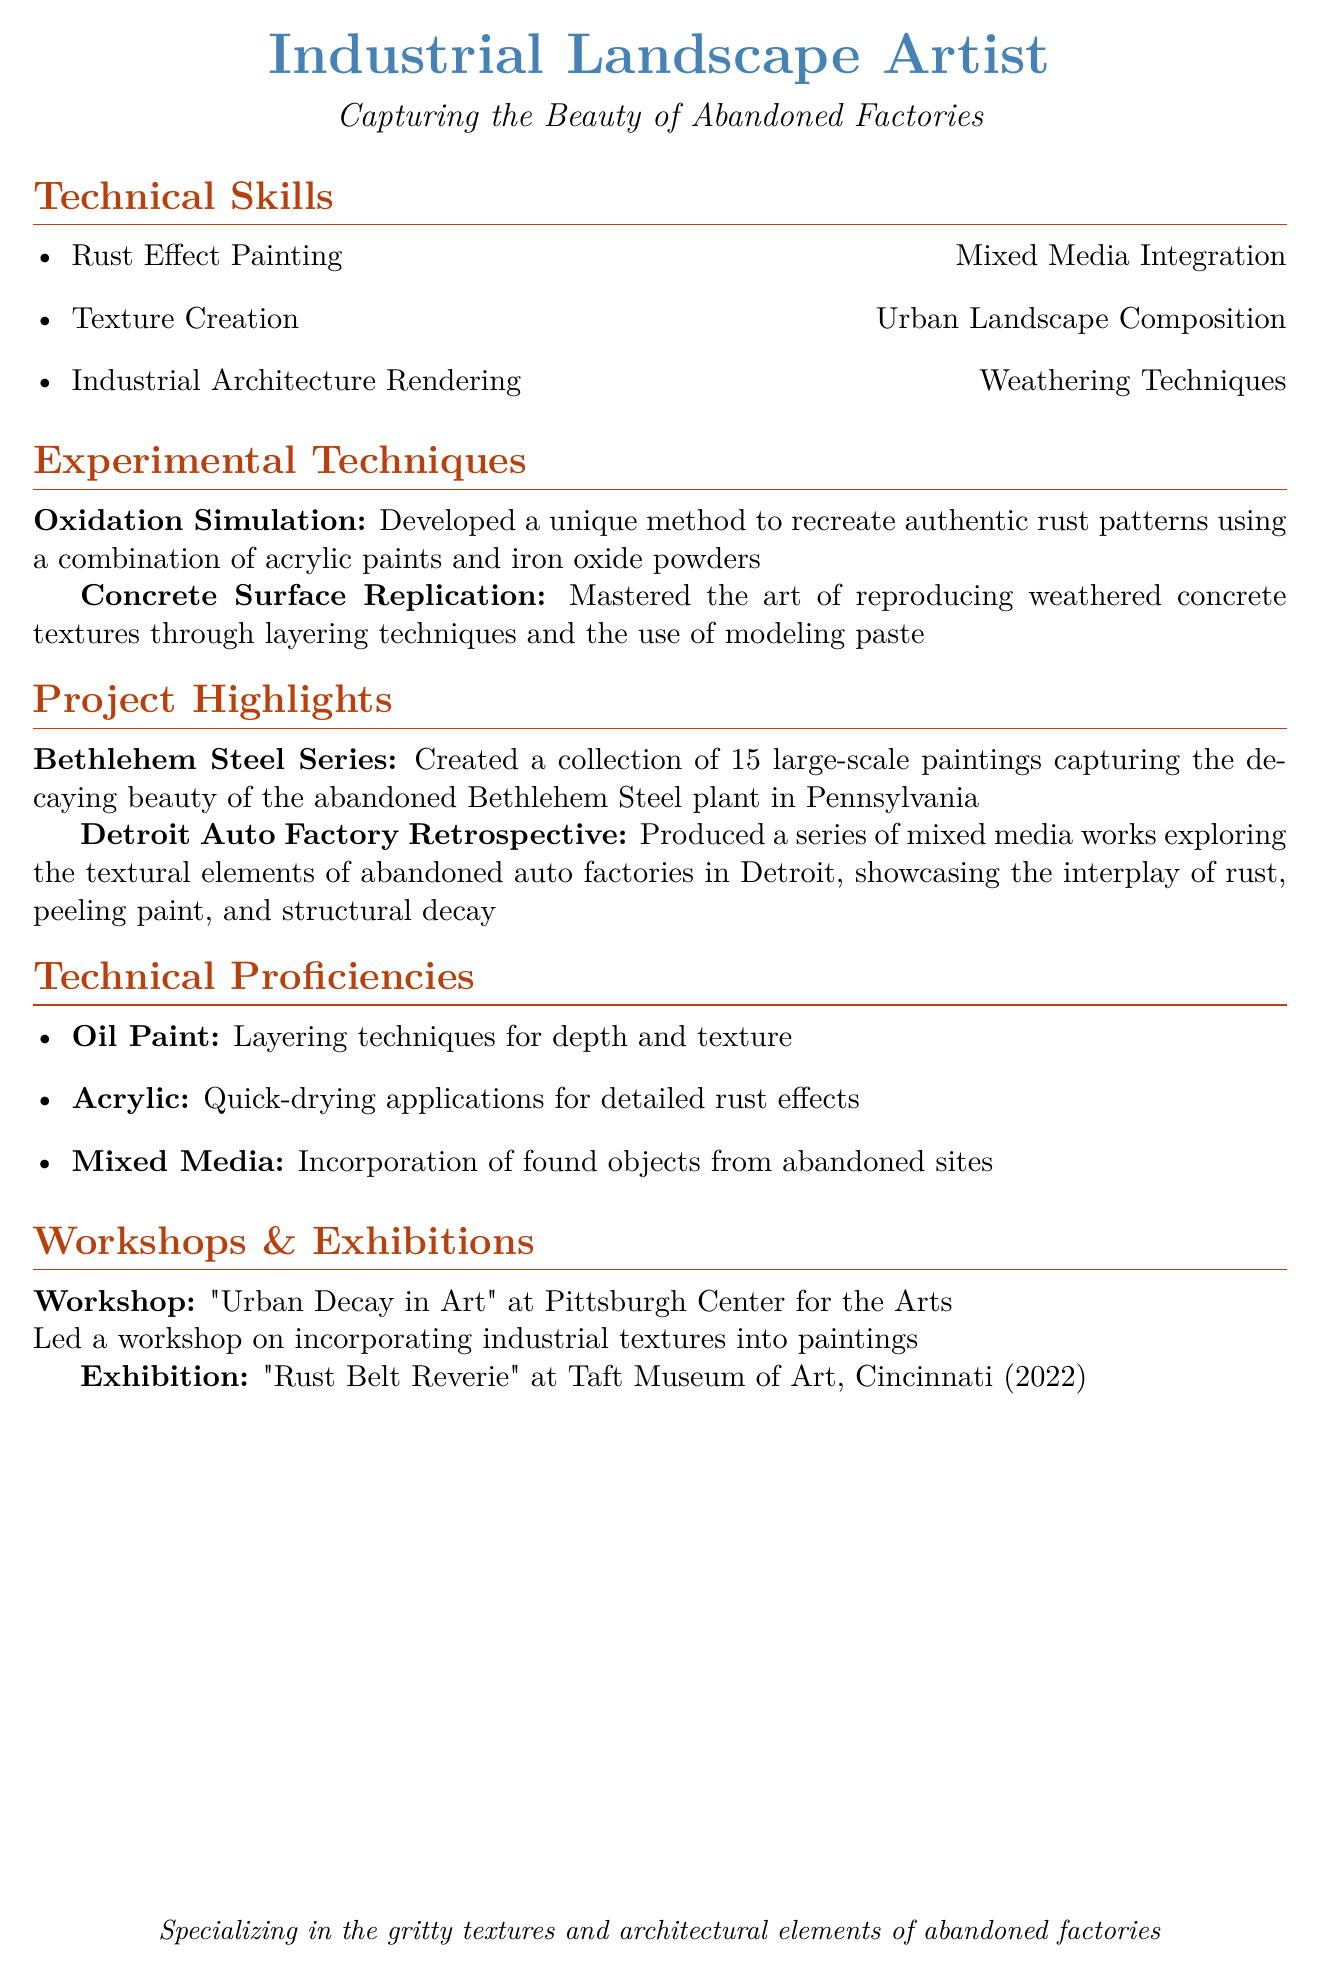What are the two experimental techniques listed? The document lists "Oxidation Simulation" and "Concrete Surface Replication" as experimental techniques.
Answer: Oxidation Simulation, Concrete Surface Replication How many paintings are in the Bethlehem Steel Series? The document states that the Bethlehem Steel Series consists of 15 large-scale paintings.
Answer: 15 What is the title of the workshop led at the Pittsburgh Center for the Arts? The document specifies the workshop title as "Urban Decay in Art."
Answer: Urban Decay in Art In what year was the exhibition "Rust Belt Reverie" held? According to the document, the exhibition "Rust Belt Reverie" was held in 2022.
Answer: 2022 What medium specializes in layering techniques for depth and texture? The document notes that oil paint is the medium that specializes in layering techniques for depth and texture.
Answer: Oil Paint What city is associated with the Detroit Auto Factory Retrospective project? The document associates the Detroit Auto Factory Retrospective with Detroit.
Answer: Detroit Which gallery hosted the "Rust Belt Reverie" exhibition? The document indicates that the Taft Museum of Art hosted the "Rust Belt Reverie" exhibition.
Answer: Taft Museum of Art 